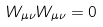<formula> <loc_0><loc_0><loc_500><loc_500>W _ { \mu \nu } W _ { \mu \nu } = 0</formula> 